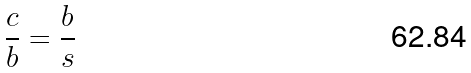<formula> <loc_0><loc_0><loc_500><loc_500>\frac { c } { b } = \frac { b } { s }</formula> 